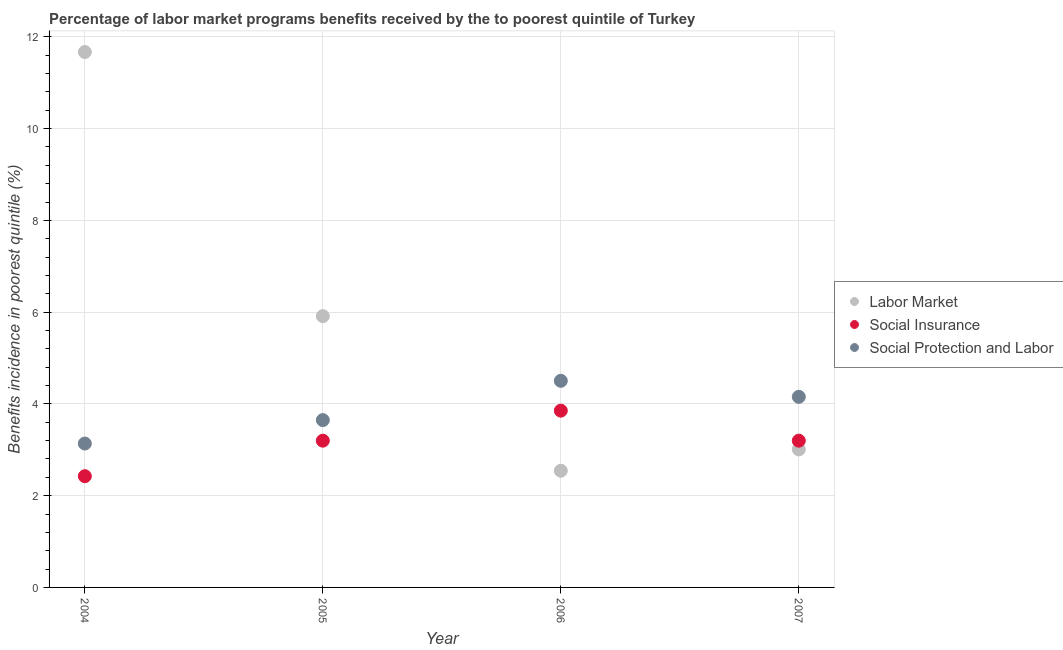How many different coloured dotlines are there?
Offer a terse response. 3. Is the number of dotlines equal to the number of legend labels?
Give a very brief answer. Yes. What is the percentage of benefits received due to labor market programs in 2005?
Ensure brevity in your answer.  5.91. Across all years, what is the maximum percentage of benefits received due to social protection programs?
Keep it short and to the point. 4.5. Across all years, what is the minimum percentage of benefits received due to social insurance programs?
Give a very brief answer. 2.42. In which year was the percentage of benefits received due to social protection programs minimum?
Your answer should be compact. 2004. What is the total percentage of benefits received due to social insurance programs in the graph?
Provide a succinct answer. 12.67. What is the difference between the percentage of benefits received due to social insurance programs in 2005 and that in 2006?
Offer a very short reply. -0.65. What is the difference between the percentage of benefits received due to social protection programs in 2007 and the percentage of benefits received due to social insurance programs in 2004?
Make the answer very short. 1.73. What is the average percentage of benefits received due to labor market programs per year?
Give a very brief answer. 5.78. In the year 2004, what is the difference between the percentage of benefits received due to labor market programs and percentage of benefits received due to social insurance programs?
Provide a succinct answer. 9.24. In how many years, is the percentage of benefits received due to social insurance programs greater than 2.8 %?
Make the answer very short. 3. What is the ratio of the percentage of benefits received due to social insurance programs in 2005 to that in 2007?
Give a very brief answer. 1. Is the percentage of benefits received due to labor market programs in 2005 less than that in 2007?
Your answer should be compact. No. What is the difference between the highest and the second highest percentage of benefits received due to social insurance programs?
Your response must be concise. 0.65. What is the difference between the highest and the lowest percentage of benefits received due to social protection programs?
Your response must be concise. 1.37. In how many years, is the percentage of benefits received due to labor market programs greater than the average percentage of benefits received due to labor market programs taken over all years?
Your answer should be compact. 2. Is the sum of the percentage of benefits received due to social insurance programs in 2004 and 2006 greater than the maximum percentage of benefits received due to labor market programs across all years?
Your answer should be very brief. No. Is the percentage of benefits received due to labor market programs strictly greater than the percentage of benefits received due to social protection programs over the years?
Your answer should be very brief. No. Is the percentage of benefits received due to labor market programs strictly less than the percentage of benefits received due to social protection programs over the years?
Your response must be concise. No. What is the difference between two consecutive major ticks on the Y-axis?
Your response must be concise. 2. How many legend labels are there?
Provide a succinct answer. 3. How are the legend labels stacked?
Offer a terse response. Vertical. What is the title of the graph?
Provide a succinct answer. Percentage of labor market programs benefits received by the to poorest quintile of Turkey. What is the label or title of the X-axis?
Keep it short and to the point. Year. What is the label or title of the Y-axis?
Your answer should be very brief. Benefits incidence in poorest quintile (%). What is the Benefits incidence in poorest quintile (%) of Labor Market in 2004?
Give a very brief answer. 11.67. What is the Benefits incidence in poorest quintile (%) of Social Insurance in 2004?
Your answer should be very brief. 2.42. What is the Benefits incidence in poorest quintile (%) in Social Protection and Labor in 2004?
Keep it short and to the point. 3.14. What is the Benefits incidence in poorest quintile (%) of Labor Market in 2005?
Your response must be concise. 5.91. What is the Benefits incidence in poorest quintile (%) of Social Insurance in 2005?
Your response must be concise. 3.2. What is the Benefits incidence in poorest quintile (%) in Social Protection and Labor in 2005?
Make the answer very short. 3.65. What is the Benefits incidence in poorest quintile (%) of Labor Market in 2006?
Give a very brief answer. 2.54. What is the Benefits incidence in poorest quintile (%) of Social Insurance in 2006?
Provide a succinct answer. 3.85. What is the Benefits incidence in poorest quintile (%) of Social Protection and Labor in 2006?
Offer a terse response. 4.5. What is the Benefits incidence in poorest quintile (%) of Labor Market in 2007?
Your response must be concise. 3.01. What is the Benefits incidence in poorest quintile (%) in Social Insurance in 2007?
Make the answer very short. 3.2. What is the Benefits incidence in poorest quintile (%) of Social Protection and Labor in 2007?
Your answer should be compact. 4.15. Across all years, what is the maximum Benefits incidence in poorest quintile (%) in Labor Market?
Your response must be concise. 11.67. Across all years, what is the maximum Benefits incidence in poorest quintile (%) in Social Insurance?
Offer a very short reply. 3.85. Across all years, what is the maximum Benefits incidence in poorest quintile (%) in Social Protection and Labor?
Your answer should be very brief. 4.5. Across all years, what is the minimum Benefits incidence in poorest quintile (%) of Labor Market?
Offer a terse response. 2.54. Across all years, what is the minimum Benefits incidence in poorest quintile (%) in Social Insurance?
Your response must be concise. 2.42. Across all years, what is the minimum Benefits incidence in poorest quintile (%) in Social Protection and Labor?
Your response must be concise. 3.14. What is the total Benefits incidence in poorest quintile (%) in Labor Market in the graph?
Give a very brief answer. 23.13. What is the total Benefits incidence in poorest quintile (%) of Social Insurance in the graph?
Your answer should be compact. 12.67. What is the total Benefits incidence in poorest quintile (%) in Social Protection and Labor in the graph?
Your response must be concise. 15.44. What is the difference between the Benefits incidence in poorest quintile (%) in Labor Market in 2004 and that in 2005?
Keep it short and to the point. 5.76. What is the difference between the Benefits incidence in poorest quintile (%) in Social Insurance in 2004 and that in 2005?
Keep it short and to the point. -0.77. What is the difference between the Benefits incidence in poorest quintile (%) of Social Protection and Labor in 2004 and that in 2005?
Your answer should be compact. -0.51. What is the difference between the Benefits incidence in poorest quintile (%) of Labor Market in 2004 and that in 2006?
Your answer should be compact. 9.13. What is the difference between the Benefits incidence in poorest quintile (%) of Social Insurance in 2004 and that in 2006?
Your answer should be compact. -1.43. What is the difference between the Benefits incidence in poorest quintile (%) of Social Protection and Labor in 2004 and that in 2006?
Provide a succinct answer. -1.37. What is the difference between the Benefits incidence in poorest quintile (%) of Labor Market in 2004 and that in 2007?
Your answer should be compact. 8.66. What is the difference between the Benefits incidence in poorest quintile (%) in Social Insurance in 2004 and that in 2007?
Your answer should be compact. -0.77. What is the difference between the Benefits incidence in poorest quintile (%) in Social Protection and Labor in 2004 and that in 2007?
Offer a very short reply. -1.02. What is the difference between the Benefits incidence in poorest quintile (%) in Labor Market in 2005 and that in 2006?
Provide a short and direct response. 3.37. What is the difference between the Benefits incidence in poorest quintile (%) of Social Insurance in 2005 and that in 2006?
Your answer should be very brief. -0.65. What is the difference between the Benefits incidence in poorest quintile (%) in Social Protection and Labor in 2005 and that in 2006?
Offer a very short reply. -0.86. What is the difference between the Benefits incidence in poorest quintile (%) in Labor Market in 2005 and that in 2007?
Offer a terse response. 2.9. What is the difference between the Benefits incidence in poorest quintile (%) of Social Protection and Labor in 2005 and that in 2007?
Offer a very short reply. -0.51. What is the difference between the Benefits incidence in poorest quintile (%) of Labor Market in 2006 and that in 2007?
Ensure brevity in your answer.  -0.46. What is the difference between the Benefits incidence in poorest quintile (%) of Social Insurance in 2006 and that in 2007?
Your response must be concise. 0.65. What is the difference between the Benefits incidence in poorest quintile (%) in Social Protection and Labor in 2006 and that in 2007?
Offer a very short reply. 0.35. What is the difference between the Benefits incidence in poorest quintile (%) in Labor Market in 2004 and the Benefits incidence in poorest quintile (%) in Social Insurance in 2005?
Your answer should be very brief. 8.47. What is the difference between the Benefits incidence in poorest quintile (%) of Labor Market in 2004 and the Benefits incidence in poorest quintile (%) of Social Protection and Labor in 2005?
Offer a very short reply. 8.02. What is the difference between the Benefits incidence in poorest quintile (%) in Social Insurance in 2004 and the Benefits incidence in poorest quintile (%) in Social Protection and Labor in 2005?
Your answer should be compact. -1.22. What is the difference between the Benefits incidence in poorest quintile (%) of Labor Market in 2004 and the Benefits incidence in poorest quintile (%) of Social Insurance in 2006?
Keep it short and to the point. 7.82. What is the difference between the Benefits incidence in poorest quintile (%) in Labor Market in 2004 and the Benefits incidence in poorest quintile (%) in Social Protection and Labor in 2006?
Your response must be concise. 7.17. What is the difference between the Benefits incidence in poorest quintile (%) of Social Insurance in 2004 and the Benefits incidence in poorest quintile (%) of Social Protection and Labor in 2006?
Your response must be concise. -2.08. What is the difference between the Benefits incidence in poorest quintile (%) of Labor Market in 2004 and the Benefits incidence in poorest quintile (%) of Social Insurance in 2007?
Your answer should be compact. 8.47. What is the difference between the Benefits incidence in poorest quintile (%) in Labor Market in 2004 and the Benefits incidence in poorest quintile (%) in Social Protection and Labor in 2007?
Ensure brevity in your answer.  7.51. What is the difference between the Benefits incidence in poorest quintile (%) in Social Insurance in 2004 and the Benefits incidence in poorest quintile (%) in Social Protection and Labor in 2007?
Your answer should be compact. -1.73. What is the difference between the Benefits incidence in poorest quintile (%) of Labor Market in 2005 and the Benefits incidence in poorest quintile (%) of Social Insurance in 2006?
Your answer should be very brief. 2.06. What is the difference between the Benefits incidence in poorest quintile (%) of Labor Market in 2005 and the Benefits incidence in poorest quintile (%) of Social Protection and Labor in 2006?
Ensure brevity in your answer.  1.41. What is the difference between the Benefits incidence in poorest quintile (%) of Social Insurance in 2005 and the Benefits incidence in poorest quintile (%) of Social Protection and Labor in 2006?
Provide a short and direct response. -1.3. What is the difference between the Benefits incidence in poorest quintile (%) of Labor Market in 2005 and the Benefits incidence in poorest quintile (%) of Social Insurance in 2007?
Provide a succinct answer. 2.71. What is the difference between the Benefits incidence in poorest quintile (%) of Labor Market in 2005 and the Benefits incidence in poorest quintile (%) of Social Protection and Labor in 2007?
Give a very brief answer. 1.76. What is the difference between the Benefits incidence in poorest quintile (%) of Social Insurance in 2005 and the Benefits incidence in poorest quintile (%) of Social Protection and Labor in 2007?
Provide a succinct answer. -0.96. What is the difference between the Benefits incidence in poorest quintile (%) of Labor Market in 2006 and the Benefits incidence in poorest quintile (%) of Social Insurance in 2007?
Your response must be concise. -0.66. What is the difference between the Benefits incidence in poorest quintile (%) of Labor Market in 2006 and the Benefits incidence in poorest quintile (%) of Social Protection and Labor in 2007?
Keep it short and to the point. -1.61. What is the difference between the Benefits incidence in poorest quintile (%) in Social Insurance in 2006 and the Benefits incidence in poorest quintile (%) in Social Protection and Labor in 2007?
Provide a succinct answer. -0.3. What is the average Benefits incidence in poorest quintile (%) of Labor Market per year?
Provide a short and direct response. 5.78. What is the average Benefits incidence in poorest quintile (%) in Social Insurance per year?
Your answer should be compact. 3.17. What is the average Benefits incidence in poorest quintile (%) of Social Protection and Labor per year?
Offer a terse response. 3.86. In the year 2004, what is the difference between the Benefits incidence in poorest quintile (%) of Labor Market and Benefits incidence in poorest quintile (%) of Social Insurance?
Give a very brief answer. 9.24. In the year 2004, what is the difference between the Benefits incidence in poorest quintile (%) in Labor Market and Benefits incidence in poorest quintile (%) in Social Protection and Labor?
Your answer should be very brief. 8.53. In the year 2004, what is the difference between the Benefits incidence in poorest quintile (%) in Social Insurance and Benefits incidence in poorest quintile (%) in Social Protection and Labor?
Keep it short and to the point. -0.71. In the year 2005, what is the difference between the Benefits incidence in poorest quintile (%) in Labor Market and Benefits incidence in poorest quintile (%) in Social Insurance?
Offer a very short reply. 2.71. In the year 2005, what is the difference between the Benefits incidence in poorest quintile (%) in Labor Market and Benefits incidence in poorest quintile (%) in Social Protection and Labor?
Offer a very short reply. 2.27. In the year 2005, what is the difference between the Benefits incidence in poorest quintile (%) of Social Insurance and Benefits incidence in poorest quintile (%) of Social Protection and Labor?
Provide a succinct answer. -0.45. In the year 2006, what is the difference between the Benefits incidence in poorest quintile (%) in Labor Market and Benefits incidence in poorest quintile (%) in Social Insurance?
Give a very brief answer. -1.31. In the year 2006, what is the difference between the Benefits incidence in poorest quintile (%) of Labor Market and Benefits incidence in poorest quintile (%) of Social Protection and Labor?
Your response must be concise. -1.96. In the year 2006, what is the difference between the Benefits incidence in poorest quintile (%) in Social Insurance and Benefits incidence in poorest quintile (%) in Social Protection and Labor?
Provide a succinct answer. -0.65. In the year 2007, what is the difference between the Benefits incidence in poorest quintile (%) of Labor Market and Benefits incidence in poorest quintile (%) of Social Insurance?
Provide a succinct answer. -0.19. In the year 2007, what is the difference between the Benefits incidence in poorest quintile (%) of Labor Market and Benefits incidence in poorest quintile (%) of Social Protection and Labor?
Provide a succinct answer. -1.15. In the year 2007, what is the difference between the Benefits incidence in poorest quintile (%) of Social Insurance and Benefits incidence in poorest quintile (%) of Social Protection and Labor?
Ensure brevity in your answer.  -0.96. What is the ratio of the Benefits incidence in poorest quintile (%) of Labor Market in 2004 to that in 2005?
Provide a short and direct response. 1.97. What is the ratio of the Benefits incidence in poorest quintile (%) in Social Insurance in 2004 to that in 2005?
Provide a succinct answer. 0.76. What is the ratio of the Benefits incidence in poorest quintile (%) in Social Protection and Labor in 2004 to that in 2005?
Your response must be concise. 0.86. What is the ratio of the Benefits incidence in poorest quintile (%) in Labor Market in 2004 to that in 2006?
Keep it short and to the point. 4.59. What is the ratio of the Benefits incidence in poorest quintile (%) in Social Insurance in 2004 to that in 2006?
Your answer should be compact. 0.63. What is the ratio of the Benefits incidence in poorest quintile (%) in Social Protection and Labor in 2004 to that in 2006?
Make the answer very short. 0.7. What is the ratio of the Benefits incidence in poorest quintile (%) of Labor Market in 2004 to that in 2007?
Make the answer very short. 3.88. What is the ratio of the Benefits incidence in poorest quintile (%) in Social Insurance in 2004 to that in 2007?
Keep it short and to the point. 0.76. What is the ratio of the Benefits incidence in poorest quintile (%) of Social Protection and Labor in 2004 to that in 2007?
Give a very brief answer. 0.76. What is the ratio of the Benefits incidence in poorest quintile (%) in Labor Market in 2005 to that in 2006?
Offer a very short reply. 2.32. What is the ratio of the Benefits incidence in poorest quintile (%) in Social Insurance in 2005 to that in 2006?
Offer a very short reply. 0.83. What is the ratio of the Benefits incidence in poorest quintile (%) in Social Protection and Labor in 2005 to that in 2006?
Offer a very short reply. 0.81. What is the ratio of the Benefits incidence in poorest quintile (%) of Labor Market in 2005 to that in 2007?
Offer a very short reply. 1.97. What is the ratio of the Benefits incidence in poorest quintile (%) of Social Insurance in 2005 to that in 2007?
Your answer should be very brief. 1. What is the ratio of the Benefits incidence in poorest quintile (%) in Social Protection and Labor in 2005 to that in 2007?
Offer a very short reply. 0.88. What is the ratio of the Benefits incidence in poorest quintile (%) in Labor Market in 2006 to that in 2007?
Ensure brevity in your answer.  0.85. What is the ratio of the Benefits incidence in poorest quintile (%) in Social Insurance in 2006 to that in 2007?
Ensure brevity in your answer.  1.2. What is the ratio of the Benefits incidence in poorest quintile (%) of Social Protection and Labor in 2006 to that in 2007?
Keep it short and to the point. 1.08. What is the difference between the highest and the second highest Benefits incidence in poorest quintile (%) of Labor Market?
Provide a succinct answer. 5.76. What is the difference between the highest and the second highest Benefits incidence in poorest quintile (%) in Social Insurance?
Provide a short and direct response. 0.65. What is the difference between the highest and the second highest Benefits incidence in poorest quintile (%) in Social Protection and Labor?
Offer a very short reply. 0.35. What is the difference between the highest and the lowest Benefits incidence in poorest quintile (%) of Labor Market?
Offer a very short reply. 9.13. What is the difference between the highest and the lowest Benefits incidence in poorest quintile (%) in Social Insurance?
Provide a succinct answer. 1.43. What is the difference between the highest and the lowest Benefits incidence in poorest quintile (%) of Social Protection and Labor?
Ensure brevity in your answer.  1.37. 